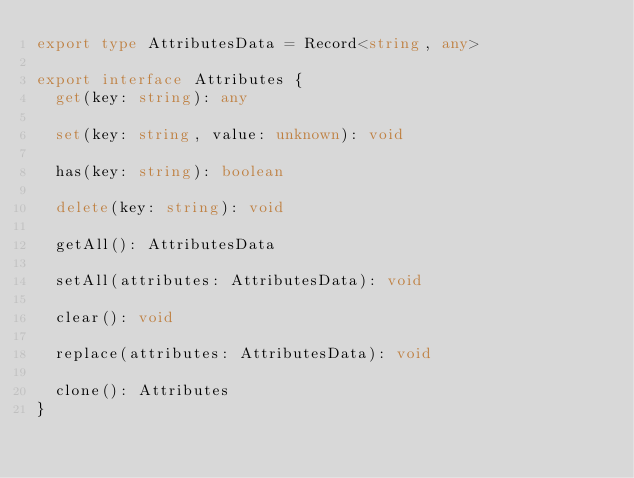<code> <loc_0><loc_0><loc_500><loc_500><_TypeScript_>export type AttributesData = Record<string, any>

export interface Attributes {
  get(key: string): any

  set(key: string, value: unknown): void

  has(key: string): boolean

  delete(key: string): void

  getAll(): AttributesData

  setAll(attributes: AttributesData): void

  clear(): void

  replace(attributes: AttributesData): void

  clone(): Attributes
}
</code> 